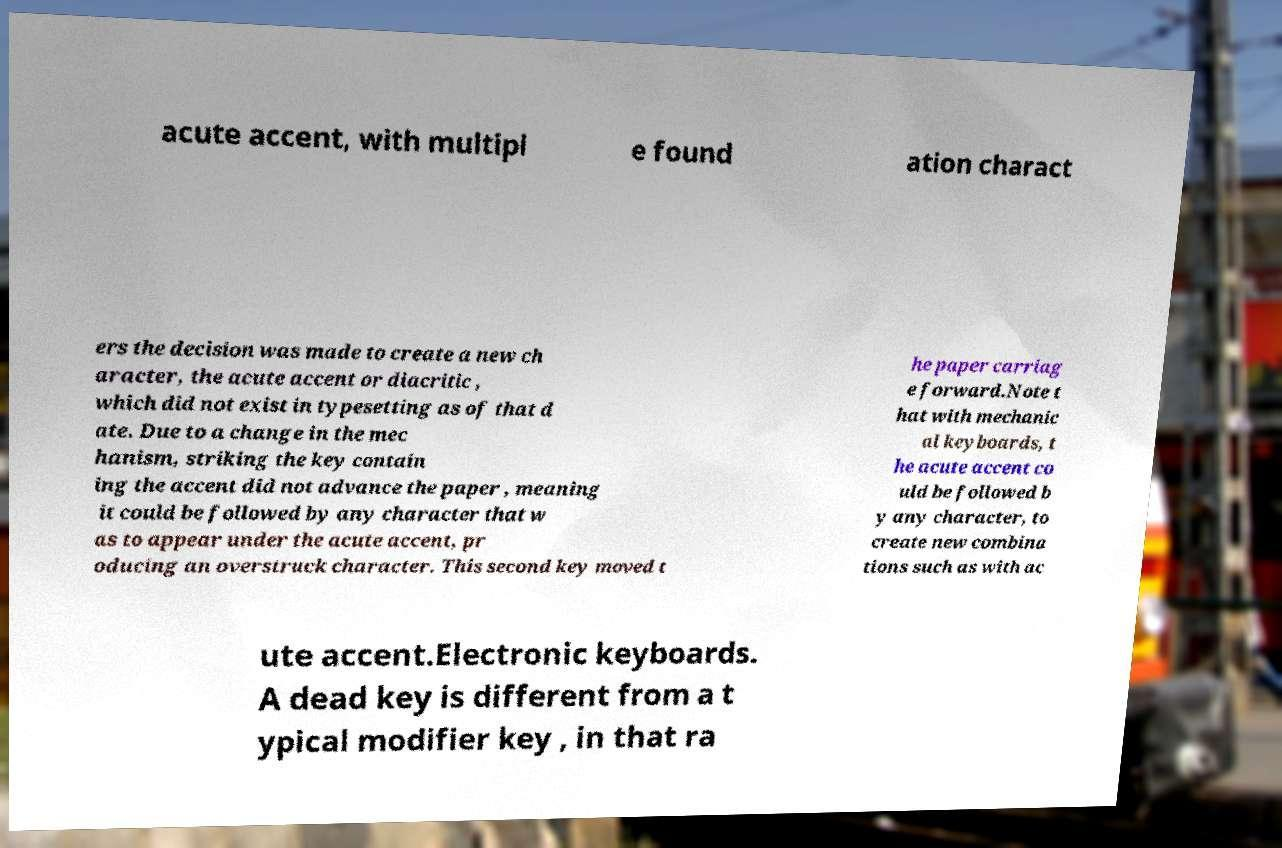Can you read and provide the text displayed in the image?This photo seems to have some interesting text. Can you extract and type it out for me? acute accent, with multipl e found ation charact ers the decision was made to create a new ch aracter, the acute accent or diacritic , which did not exist in typesetting as of that d ate. Due to a change in the mec hanism, striking the key contain ing the accent did not advance the paper , meaning it could be followed by any character that w as to appear under the acute accent, pr oducing an overstruck character. This second key moved t he paper carriag e forward.Note t hat with mechanic al keyboards, t he acute accent co uld be followed b y any character, to create new combina tions such as with ac ute accent.Electronic keyboards. A dead key is different from a t ypical modifier key , in that ra 